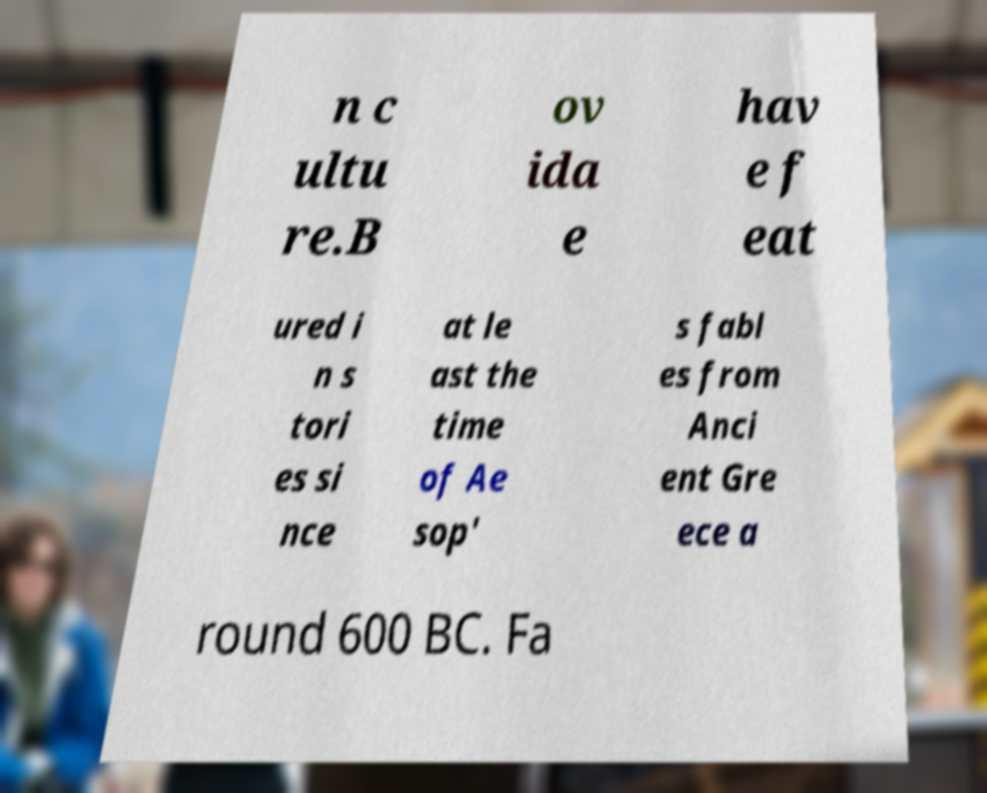For documentation purposes, I need the text within this image transcribed. Could you provide that? n c ultu re.B ov ida e hav e f eat ured i n s tori es si nce at le ast the time of Ae sop' s fabl es from Anci ent Gre ece a round 600 BC. Fa 